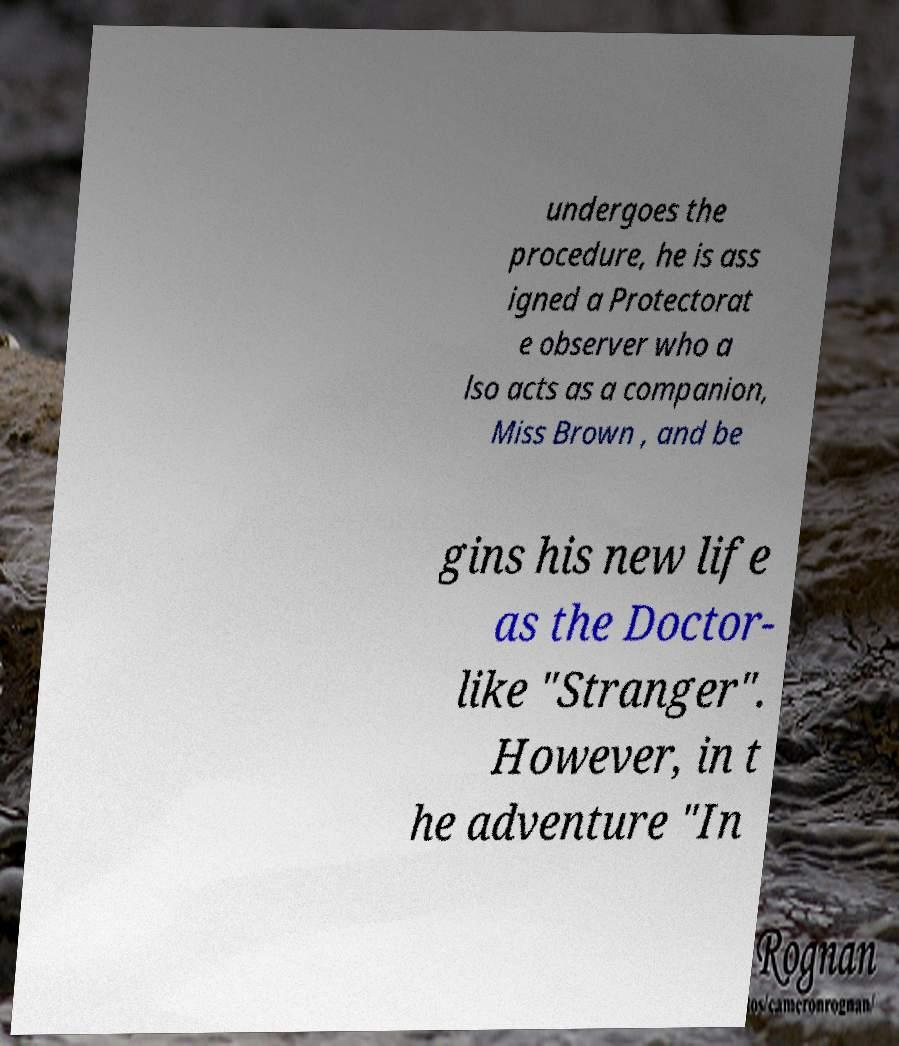Could you extract and type out the text from this image? undergoes the procedure, he is ass igned a Protectorat e observer who a lso acts as a companion, Miss Brown , and be gins his new life as the Doctor- like "Stranger". However, in t he adventure "In 